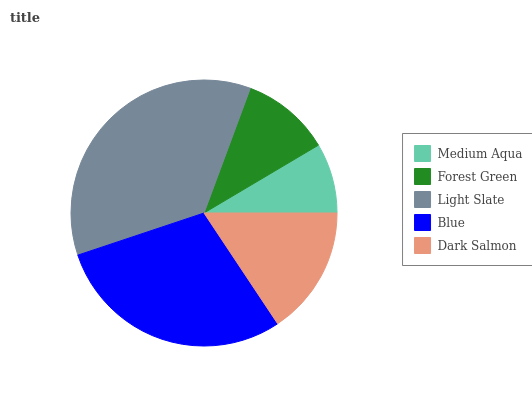Is Medium Aqua the minimum?
Answer yes or no. Yes. Is Light Slate the maximum?
Answer yes or no. Yes. Is Forest Green the minimum?
Answer yes or no. No. Is Forest Green the maximum?
Answer yes or no. No. Is Forest Green greater than Medium Aqua?
Answer yes or no. Yes. Is Medium Aqua less than Forest Green?
Answer yes or no. Yes. Is Medium Aqua greater than Forest Green?
Answer yes or no. No. Is Forest Green less than Medium Aqua?
Answer yes or no. No. Is Dark Salmon the high median?
Answer yes or no. Yes. Is Dark Salmon the low median?
Answer yes or no. Yes. Is Medium Aqua the high median?
Answer yes or no. No. Is Light Slate the low median?
Answer yes or no. No. 